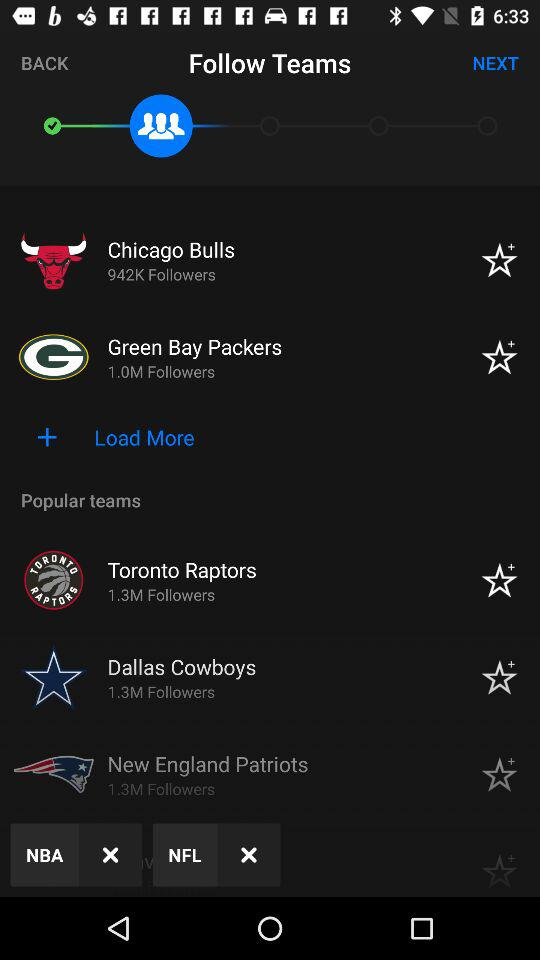How many people are following "Toronto Raptors"? The number of people that are following "Toronto Raptors" is 1.3M. 